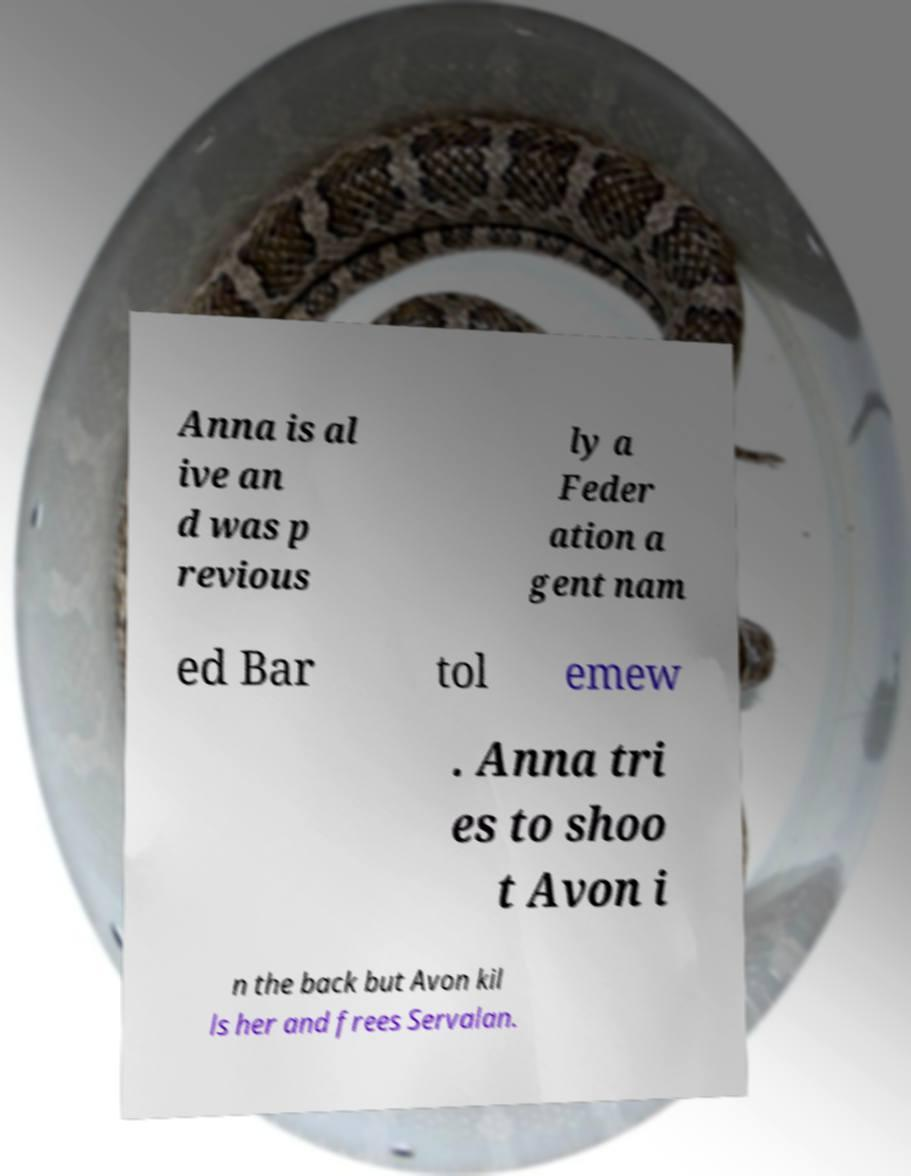I need the written content from this picture converted into text. Can you do that? Anna is al ive an d was p revious ly a Feder ation a gent nam ed Bar tol emew . Anna tri es to shoo t Avon i n the back but Avon kil ls her and frees Servalan. 